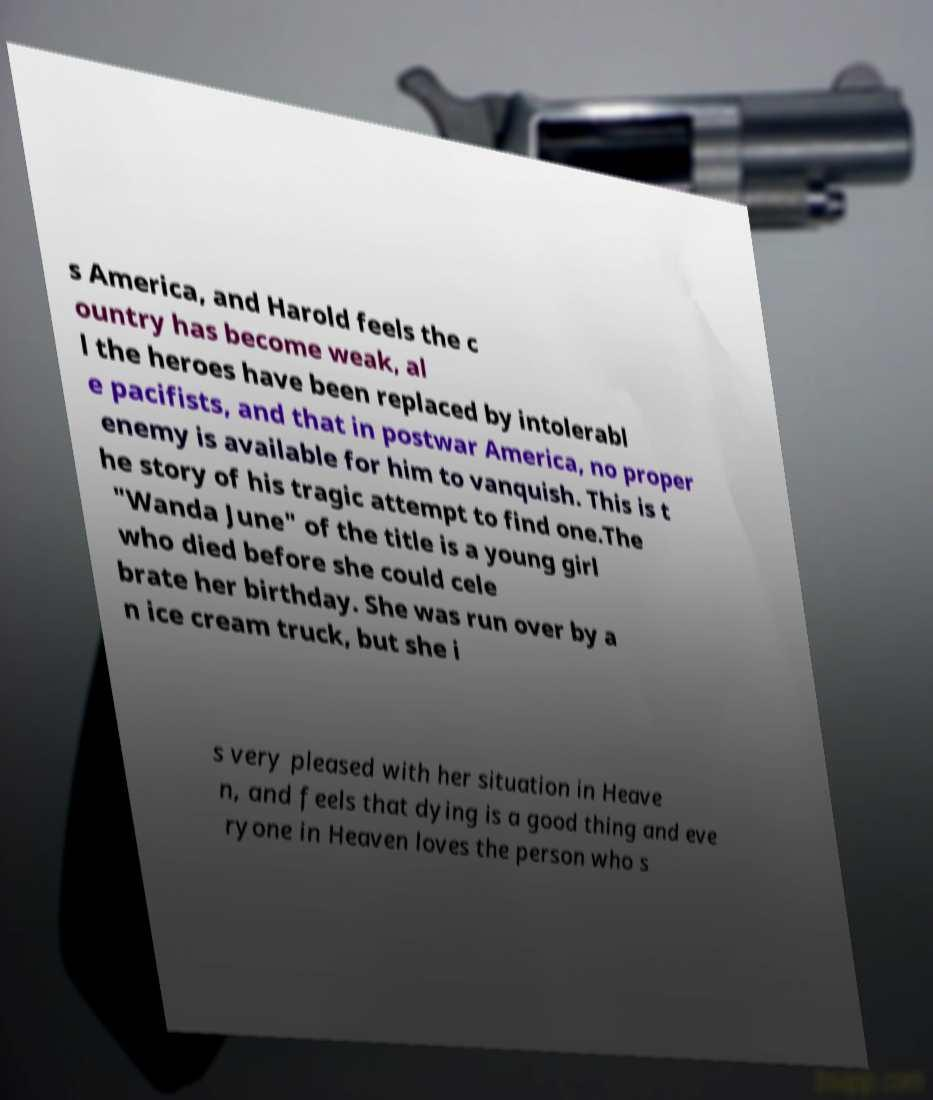There's text embedded in this image that I need extracted. Can you transcribe it verbatim? s America, and Harold feels the c ountry has become weak, al l the heroes have been replaced by intolerabl e pacifists, and that in postwar America, no proper enemy is available for him to vanquish. This is t he story of his tragic attempt to find one.The "Wanda June" of the title is a young girl who died before she could cele brate her birthday. She was run over by a n ice cream truck, but she i s very pleased with her situation in Heave n, and feels that dying is a good thing and eve ryone in Heaven loves the person who s 